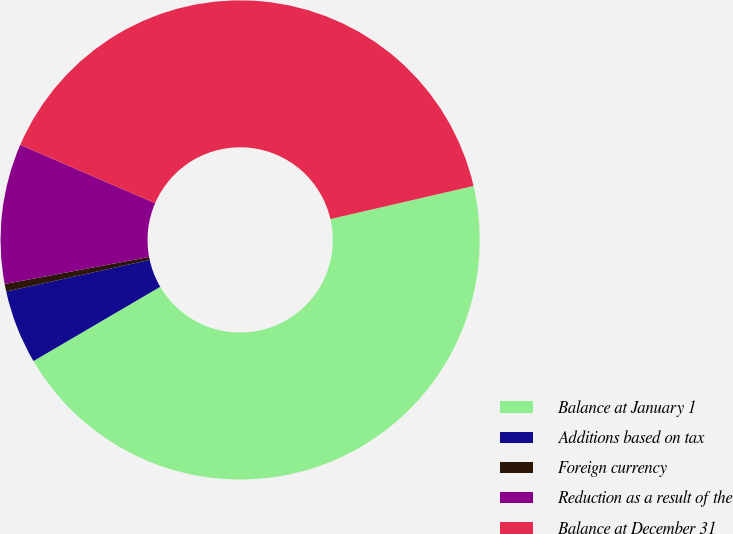<chart> <loc_0><loc_0><loc_500><loc_500><pie_chart><fcel>Balance at January 1<fcel>Additions based on tax<fcel>Foreign currency<fcel>Reduction as a result of the<fcel>Balance at December 31<nl><fcel>45.18%<fcel>4.98%<fcel>0.51%<fcel>9.44%<fcel>39.89%<nl></chart> 